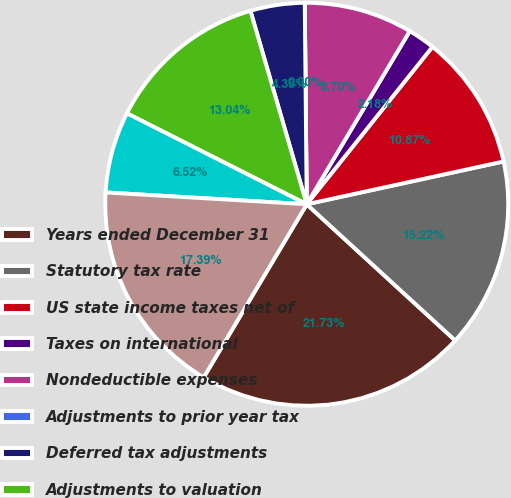Convert chart to OTSL. <chart><loc_0><loc_0><loc_500><loc_500><pie_chart><fcel>Years ended December 31<fcel>Statutory tax rate<fcel>US state income taxes net of<fcel>Taxes on international<fcel>Nondeductible expenses<fcel>Adjustments to prior year tax<fcel>Deferred tax adjustments<fcel>Adjustments to valuation<fcel>Other - net<fcel>Effective tax rate<nl><fcel>21.73%<fcel>15.22%<fcel>10.87%<fcel>2.18%<fcel>8.7%<fcel>0.0%<fcel>4.35%<fcel>13.04%<fcel>6.52%<fcel>17.39%<nl></chart> 